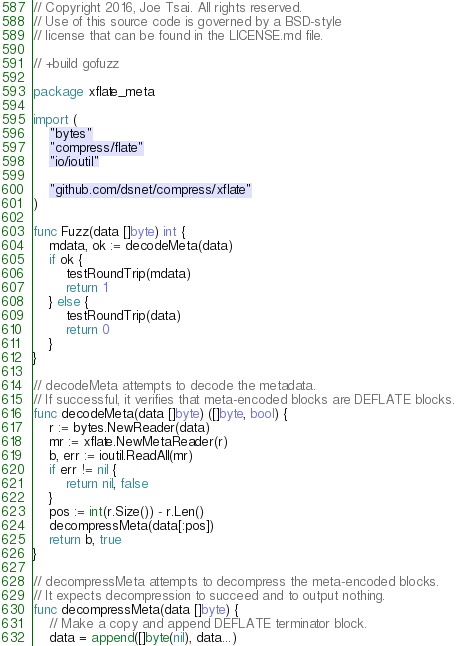<code> <loc_0><loc_0><loc_500><loc_500><_Go_>// Copyright 2016, Joe Tsai. All rights reserved.
// Use of this source code is governed by a BSD-style
// license that can be found in the LICENSE.md file.

// +build gofuzz

package xflate_meta

import (
	"bytes"
	"compress/flate"
	"io/ioutil"

	"github.com/dsnet/compress/xflate"
)

func Fuzz(data []byte) int {
	mdata, ok := decodeMeta(data)
	if ok {
		testRoundTrip(mdata)
		return 1
	} else {
		testRoundTrip(data)
		return 0
	}
}

// decodeMeta attempts to decode the metadata.
// If successful, it verifies that meta-encoded blocks are DEFLATE blocks.
func decodeMeta(data []byte) ([]byte, bool) {
	r := bytes.NewReader(data)
	mr := xflate.NewMetaReader(r)
	b, err := ioutil.ReadAll(mr)
	if err != nil {
		return nil, false
	}
	pos := int(r.Size()) - r.Len()
	decompressMeta(data[:pos])
	return b, true
}

// decompressMeta attempts to decompress the meta-encoded blocks.
// It expects decompression to succeed and to output nothing.
func decompressMeta(data []byte) {
	// Make a copy and append DEFLATE terminator block.
	data = append([]byte(nil), data...)</code> 